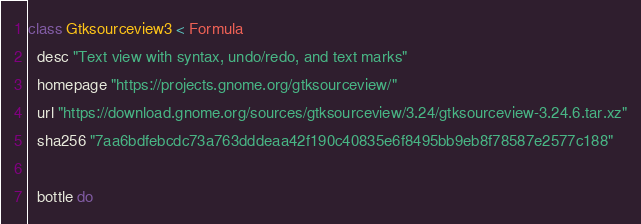<code> <loc_0><loc_0><loc_500><loc_500><_Ruby_>class Gtksourceview3 < Formula
  desc "Text view with syntax, undo/redo, and text marks"
  homepage "https://projects.gnome.org/gtksourceview/"
  url "https://download.gnome.org/sources/gtksourceview/3.24/gtksourceview-3.24.6.tar.xz"
  sha256 "7aa6bdfebcdc73a763dddeaa42f190c40835e6f8495bb9eb8f78587e2577c188"

  bottle do</code> 